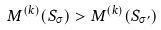<formula> <loc_0><loc_0><loc_500><loc_500>M ^ { ( k ) } ( S _ { \sigma } ) > M ^ { ( k ) } ( S _ { \sigma ^ { \prime } } )</formula> 